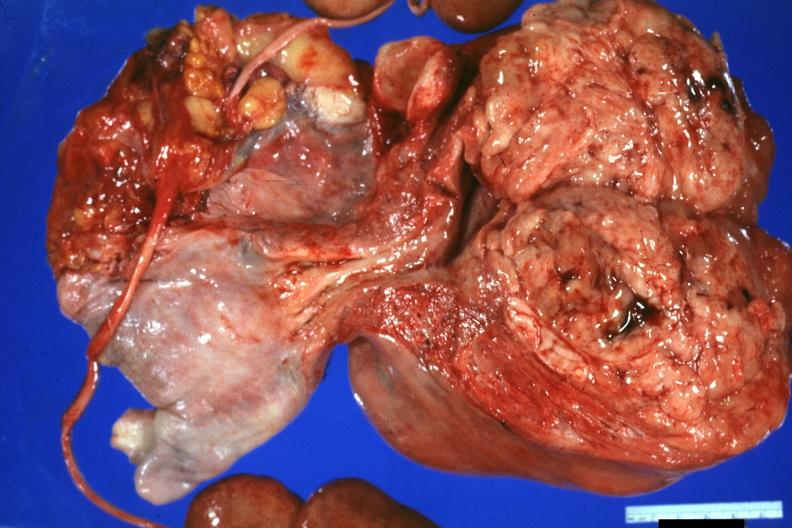s female reproductive present?
Answer the question using a single word or phrase. Yes 